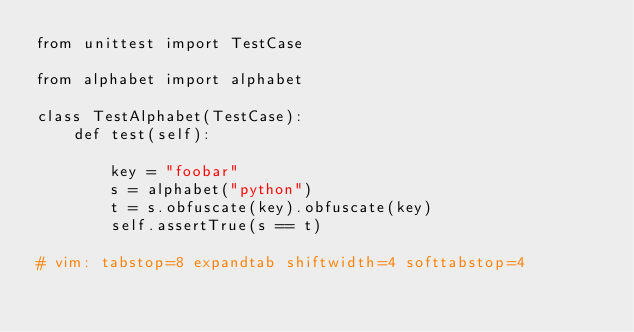Convert code to text. <code><loc_0><loc_0><loc_500><loc_500><_Python_>from unittest import TestCase

from alphabet import alphabet

class TestAlphabet(TestCase):
    def test(self):

        key = "foobar"
        s = alphabet("python")
        t = s.obfuscate(key).obfuscate(key)
        self.assertTrue(s == t)

# vim: tabstop=8 expandtab shiftwidth=4 softtabstop=4
</code> 